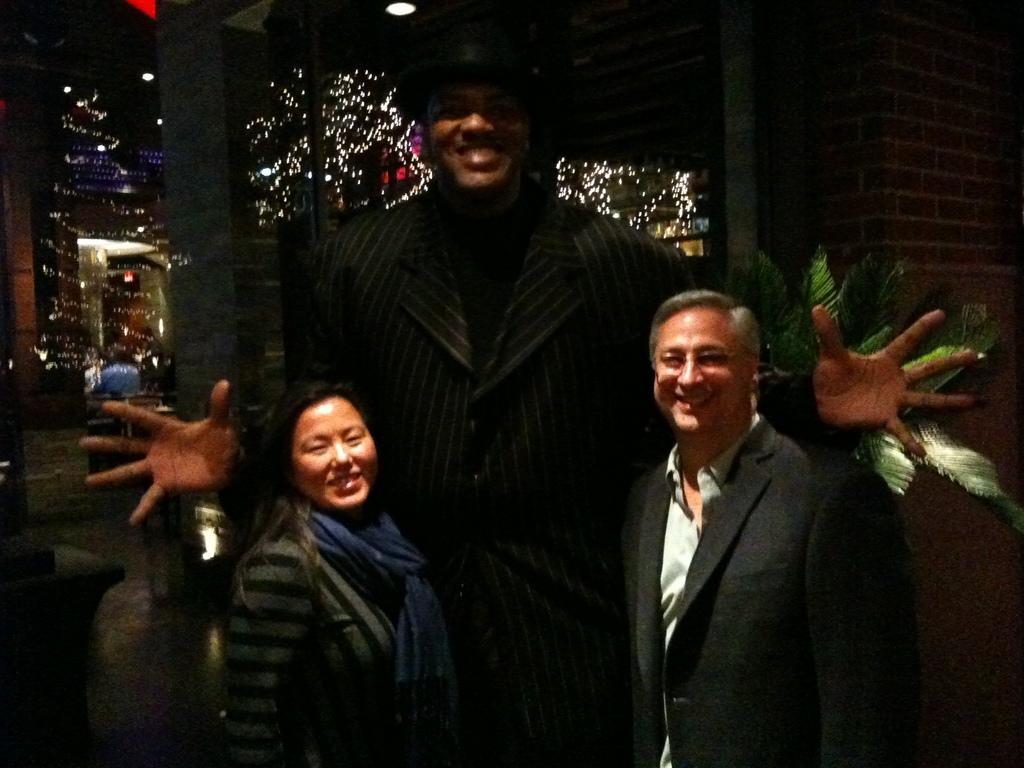Please provide a concise description of this image. In this picture we can see there are three people standing and behind the people there are house plants, wall and some decorative lights. At the top there are ceiling lights. 